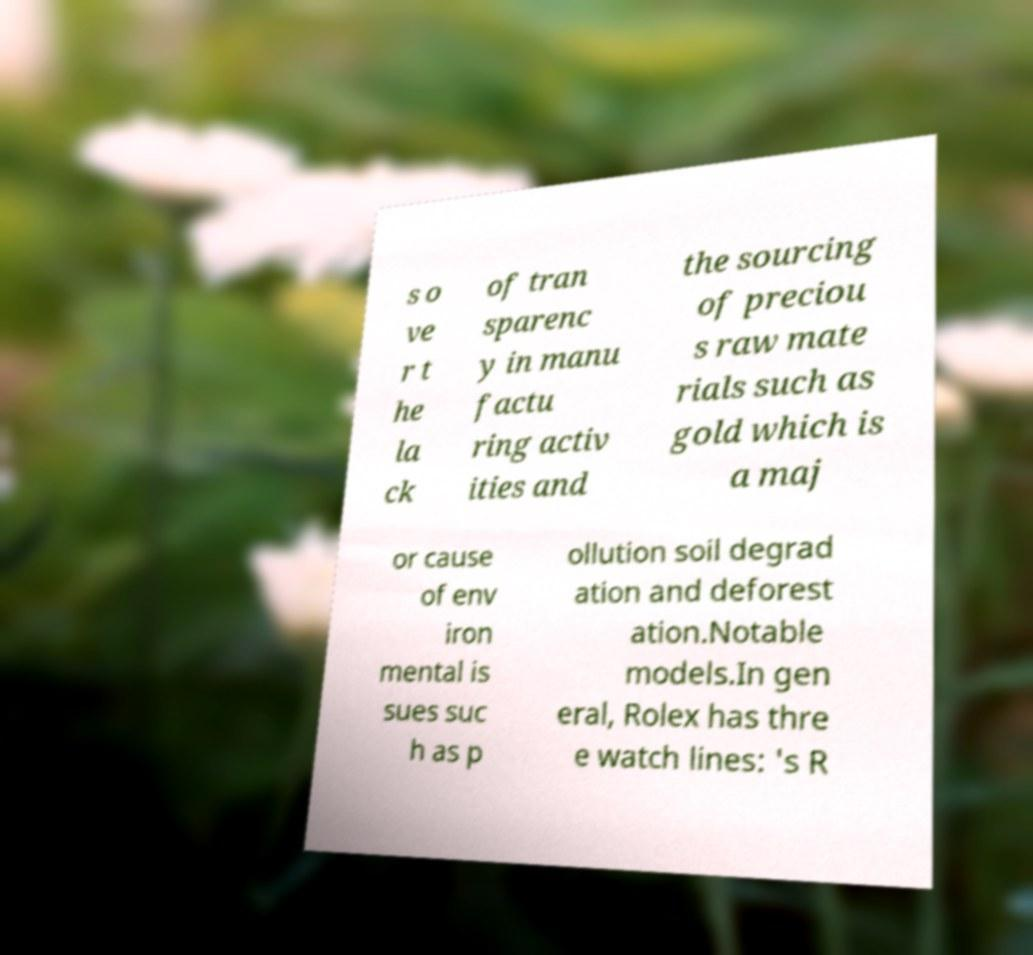There's text embedded in this image that I need extracted. Can you transcribe it verbatim? s o ve r t he la ck of tran sparenc y in manu factu ring activ ities and the sourcing of preciou s raw mate rials such as gold which is a maj or cause of env iron mental is sues suc h as p ollution soil degrad ation and deforest ation.Notable models.In gen eral, Rolex has thre e watch lines: 's R 